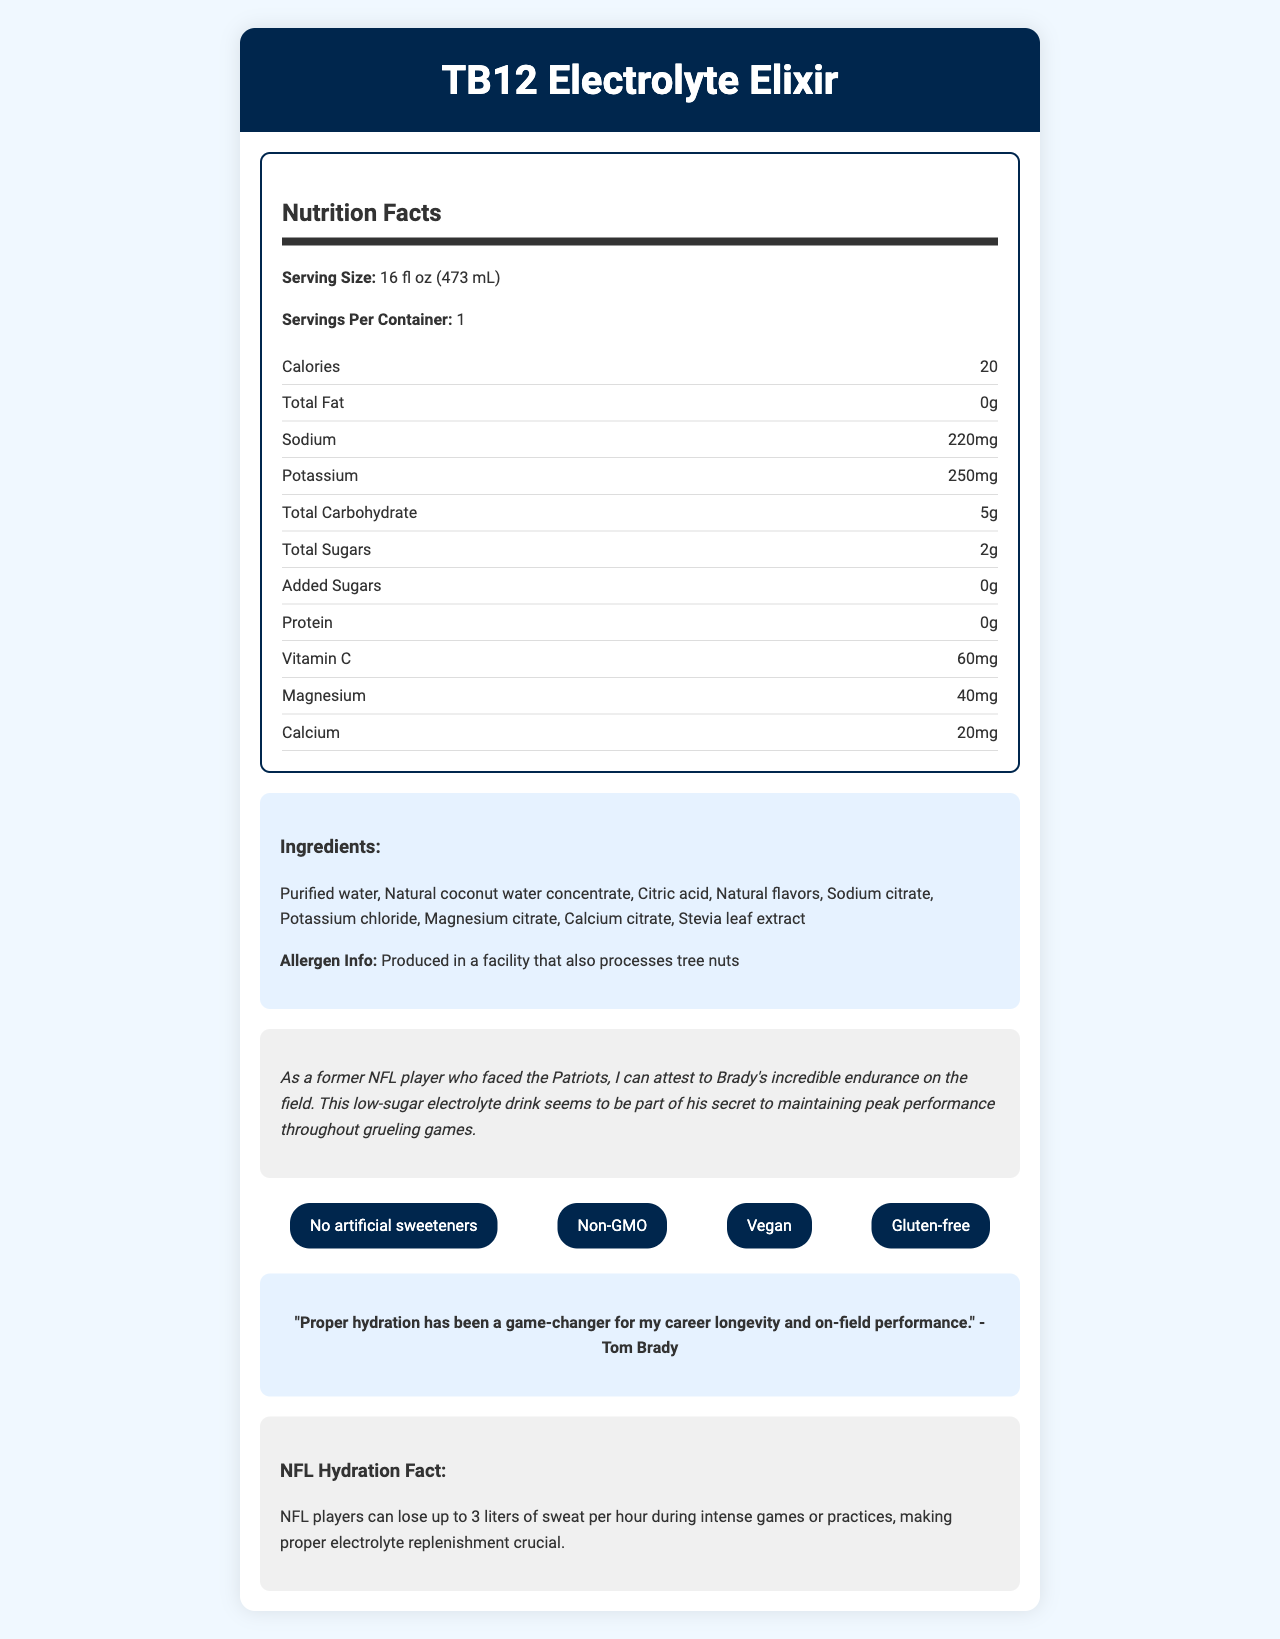what is the serving size of TB12 Electrolyte Elixir? The document states the serving size under the Nutrition Facts section.
Answer: 16 fl oz (473 mL) how many calories are in one serving of TB12 Electrolyte Elixir? The calories per serving are listed as 20 in the Nutrition Facts section.
Answer: 20 how much sodium does a serving contain? The sodium content is listed as 220mg in the nutrition information.
Answer: 220mg how much added sugar is in the beverage? The document shows "Added Sugars" as 0g.
Answer: 0g what are some of the main ingredients? The ingredients are listed under the Ingredients section.
Answer: Purified water, Natural coconut water concentrate, Citric acid, Natural flavors what vitamin is prominently listed and what is its amount? The document indicates that there is 60mg of Vitamin C in a serving.
Answer: Vitamin C, 60mg which claim is NOT part of the health claims? A. No artificial sweeteners B. Contains artificial colors C. Non-GMO D. Vegan The health claims listed include No artificial sweeteners, Non-GMO, Vegan, and Gluten-free, but not Contains artificial colors.
Answer: B where is the TB12 Electrolyte Elixir recommended to be consumed? 1. During breakfast 2. Before, during, and after intense physical activity 3. With a light meal 4. Just before bedtime The recommended use section advises consuming the beverage before, during, and after intense physical activity.
Answer: 2 is the beverage produced in a facility that processes tree nuts? The Allergen Info indicates that it is produced in a facility that also processes tree nuts.
Answer: Yes what is the main idea of the document? The document covers all aspects of the TB12 Electrolyte Elixir, including its nutritional facts, health claims, ingredients, and recommended use, as well as the endorsement from Tom Brady emphasizing its role in athletic hydration and performance.
Answer: The document provides detailed nutritional information, health claims, ingredient list, and endorsements for the TB12 Electrolyte Elixir, a low-sugar, electrolyte-rich beverage favored by Tom Brady for hydration and performance. how many milligrams of potassium are in one serving? The nutritional information states that one serving contains 250mg of potassium.
Answer: 250mg can it be determined how many facilities produce the TB12 Electrolyte Elixir? The document only states that it is produced in a facility that processes tree nuts but does not indicate the number of facilities involved in production.
Answer: Cannot be determined how does Tom Brady feel about hydration in relation to his career? This information is quoted directly from Tom Brady in the document's quote section.
Answer: Proper hydration has been a game-changer for his career longevity and on-field performance. are there any artificial sweeteners in the TB12 Electrolyte Elixir? One of the health claims listed for the beverage is "No artificial sweeteners."
Answer: No 